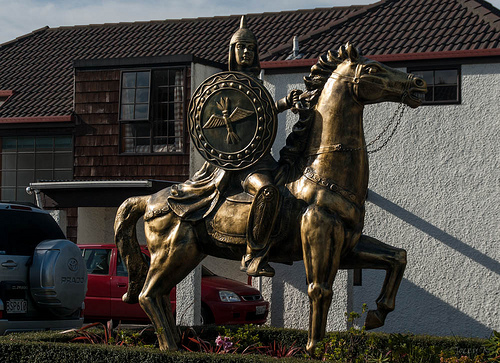<image>
Is there a statue in front of the building? Yes. The statue is positioned in front of the building, appearing closer to the camera viewpoint. 